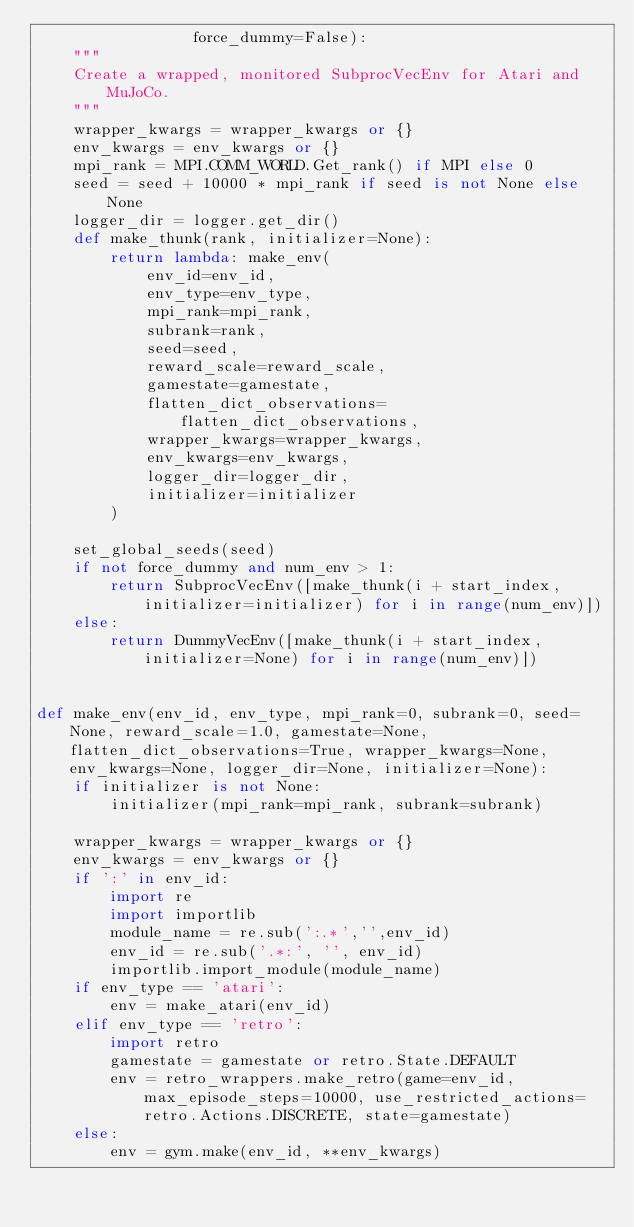<code> <loc_0><loc_0><loc_500><loc_500><_Python_>                 force_dummy=False):
    """
    Create a wrapped, monitored SubprocVecEnv for Atari and MuJoCo.
    """
    wrapper_kwargs = wrapper_kwargs or {}
    env_kwargs = env_kwargs or {}
    mpi_rank = MPI.COMM_WORLD.Get_rank() if MPI else 0
    seed = seed + 10000 * mpi_rank if seed is not None else None
    logger_dir = logger.get_dir()
    def make_thunk(rank, initializer=None):
        return lambda: make_env(
            env_id=env_id,
            env_type=env_type,
            mpi_rank=mpi_rank,
            subrank=rank,
            seed=seed,
            reward_scale=reward_scale,
            gamestate=gamestate,
            flatten_dict_observations=flatten_dict_observations,
            wrapper_kwargs=wrapper_kwargs,
            env_kwargs=env_kwargs,
            logger_dir=logger_dir,
            initializer=initializer
        )

    set_global_seeds(seed)
    if not force_dummy and num_env > 1:
        return SubprocVecEnv([make_thunk(i + start_index, initializer=initializer) for i in range(num_env)])
    else:
        return DummyVecEnv([make_thunk(i + start_index, initializer=None) for i in range(num_env)])


def make_env(env_id, env_type, mpi_rank=0, subrank=0, seed=None, reward_scale=1.0, gamestate=None, flatten_dict_observations=True, wrapper_kwargs=None, env_kwargs=None, logger_dir=None, initializer=None):
    if initializer is not None:
        initializer(mpi_rank=mpi_rank, subrank=subrank)

    wrapper_kwargs = wrapper_kwargs or {}
    env_kwargs = env_kwargs or {}
    if ':' in env_id:
        import re
        import importlib
        module_name = re.sub(':.*','',env_id)
        env_id = re.sub('.*:', '', env_id)
        importlib.import_module(module_name)
    if env_type == 'atari':
        env = make_atari(env_id)
    elif env_type == 'retro':
        import retro
        gamestate = gamestate or retro.State.DEFAULT
        env = retro_wrappers.make_retro(game=env_id, max_episode_steps=10000, use_restricted_actions=retro.Actions.DISCRETE, state=gamestate)
    else:
        env = gym.make(env_id, **env_kwargs)
</code> 